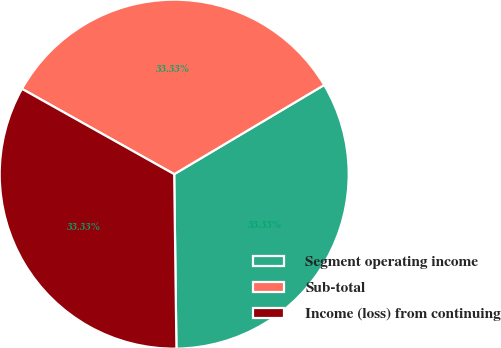Convert chart to OTSL. <chart><loc_0><loc_0><loc_500><loc_500><pie_chart><fcel>Segment operating income<fcel>Sub-total<fcel>Income (loss) from continuing<nl><fcel>33.33%<fcel>33.33%<fcel>33.33%<nl></chart> 